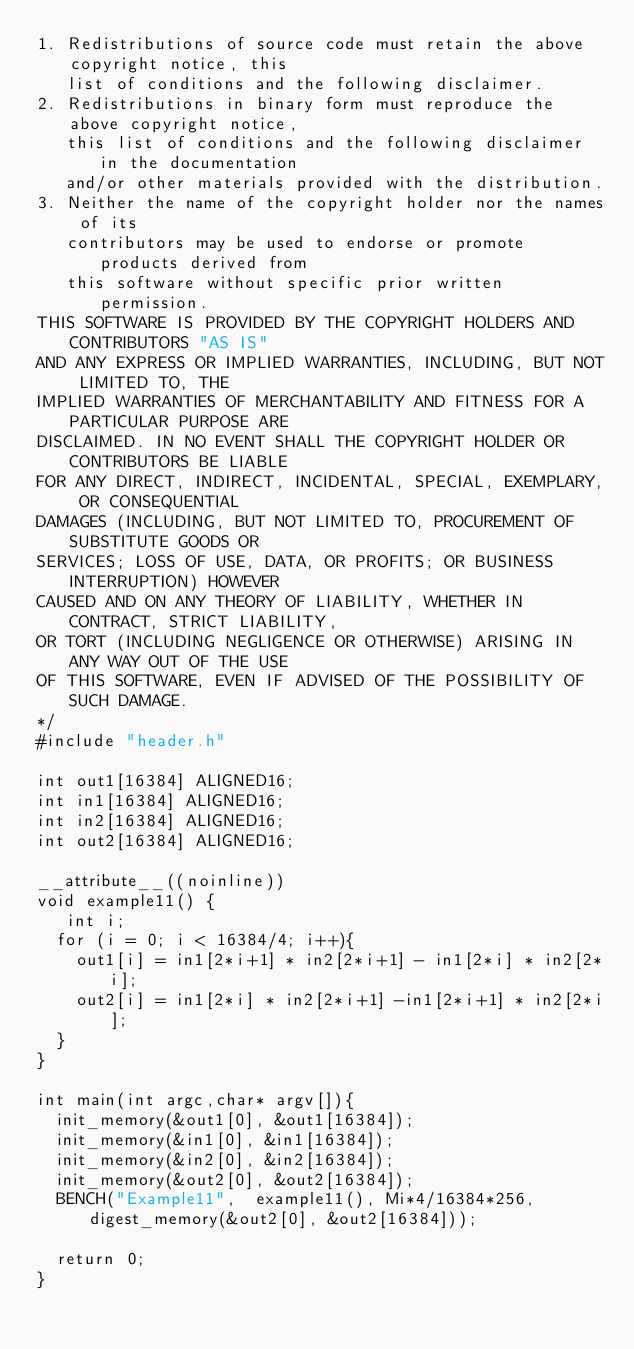<code> <loc_0><loc_0><loc_500><loc_500><_C_>1. Redistributions of source code must retain the above copyright notice, this
   list of conditions and the following disclaimer.
2. Redistributions in binary form must reproduce the above copyright notice,
   this list of conditions and the following disclaimer in the documentation
   and/or other materials provided with the distribution.
3. Neither the name of the copyright holder nor the names of its
   contributors may be used to endorse or promote products derived from
   this software without specific prior written permission.
THIS SOFTWARE IS PROVIDED BY THE COPYRIGHT HOLDERS AND CONTRIBUTORS "AS IS"
AND ANY EXPRESS OR IMPLIED WARRANTIES, INCLUDING, BUT NOT LIMITED TO, THE
IMPLIED WARRANTIES OF MERCHANTABILITY AND FITNESS FOR A PARTICULAR PURPOSE ARE
DISCLAIMED. IN NO EVENT SHALL THE COPYRIGHT HOLDER OR CONTRIBUTORS BE LIABLE
FOR ANY DIRECT, INDIRECT, INCIDENTAL, SPECIAL, EXEMPLARY, OR CONSEQUENTIAL
DAMAGES (INCLUDING, BUT NOT LIMITED TO, PROCUREMENT OF SUBSTITUTE GOODS OR
SERVICES; LOSS OF USE, DATA, OR PROFITS; OR BUSINESS INTERRUPTION) HOWEVER
CAUSED AND ON ANY THEORY OF LIABILITY, WHETHER IN CONTRACT, STRICT LIABILITY,
OR TORT (INCLUDING NEGLIGENCE OR OTHERWISE) ARISING IN ANY WAY OUT OF THE USE
OF THIS SOFTWARE, EVEN IF ADVISED OF THE POSSIBILITY OF SUCH DAMAGE.
*/
#include "header.h"

int out1[16384] ALIGNED16;
int in1[16384] ALIGNED16;
int in2[16384] ALIGNED16;
int out2[16384] ALIGNED16;

__attribute__((noinline))
void example11() {
   int i;
  for (i = 0; i < 16384/4; i++){
    out1[i] = in1[2*i+1] * in2[2*i+1] - in1[2*i] * in2[2*i];
    out2[i] = in1[2*i] * in2[2*i+1] -in1[2*i+1] * in2[2*i];
  }
}

int main(int argc,char* argv[]){
  init_memory(&out1[0], &out1[16384]);
  init_memory(&in1[0], &in1[16384]);
  init_memory(&in2[0], &in2[16384]);
  init_memory(&out2[0], &out2[16384]);
  BENCH("Example11",  example11(), Mi*4/16384*256, digest_memory(&out2[0], &out2[16384]));
 
  return 0;
}
</code> 